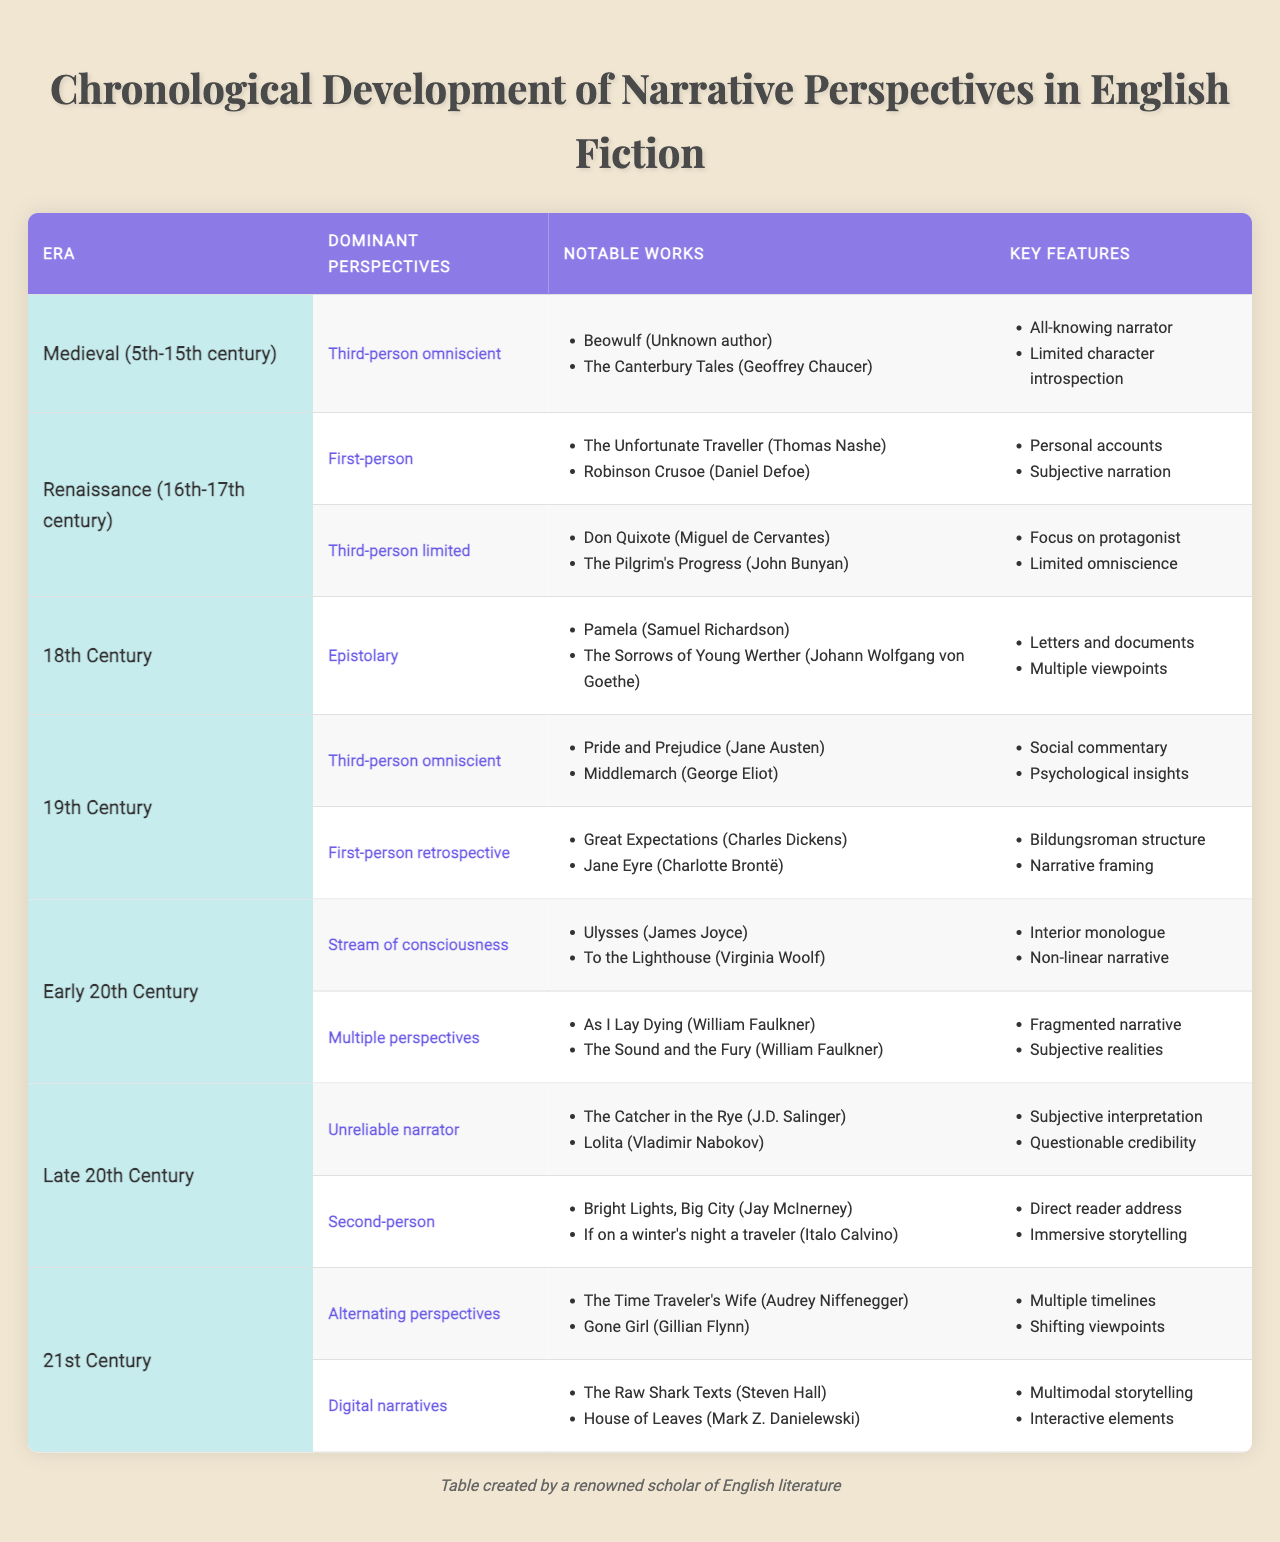What are the dominant narrative perspectives in the Medieval era? According to the table, the dominant narrative perspective in the Medieval era is "Third-person omniscient."
Answer: Third-person omniscient Which notable works are associated with the Renaissance era's first-person narrative perspective? The table lists "The Unfortunate Traveller" by Thomas Nashe and "Robinson Crusoe" by Daniel Defoe as notable works for the first-person narrative perspective.
Answer: The Unfortunate Traveller, Robinson Crusoe How many dominant narrative perspectives are listed for the 19th Century? In the table, there are two dominant narrative perspectives listed for the 19th Century: third-person omniscient and first-person retrospective.
Answer: Two Which perspective type from the Early 20th Century utilizes interior monologue and non-linear narrative features? The table indicates that the "Stream of consciousness" perspective type features interior monologue and non-linear narrative.
Answer: Stream of consciousness Is "The Sound and the Fury" classified under multiple perspectives in the 20th Century? Yes, the table confirms that "The Sound and the Fury" by William Faulkner is associated with the multiple perspectives narrative type.
Answer: Yes What are the key features of the unreliable narrator from the Late 20th Century? The key features for the unreliable narrator, according to the table, are subjective interpretation and questionable credibility.
Answer: Subjective interpretation, questionable credibility Which era features the epistolary narrative perspective, and what are its key features? The epistolary narrative perspective is featured in the 18th Century, with key features being letters and documents, as well as multiple viewpoints.
Answer: 18th Century; letters, multiple viewpoints How many notable works are cited under the 21st Century's digital narratives perspective? The table provides two notable works under the digital narratives perspective: "The Raw Shark Texts" and "House of Leaves."
Answer: Two In which era did the narrative structures emphasizing character introspection begin to emerge, and what is an example? The 19th Century marks the emergence of narrative structures emphasizing character introspection, exemplified by "Pride and Prejudice" by Jane Austen.
Answer: 19th Century, Pride and Prejudice What is the relationship between narrative perspectives and social commentary in the 19th Century? The narrative perspectives of third-person omniscient in the 19th Century are associated with social commentary, as indicated in the table.
Answer: They are related through social commentary 